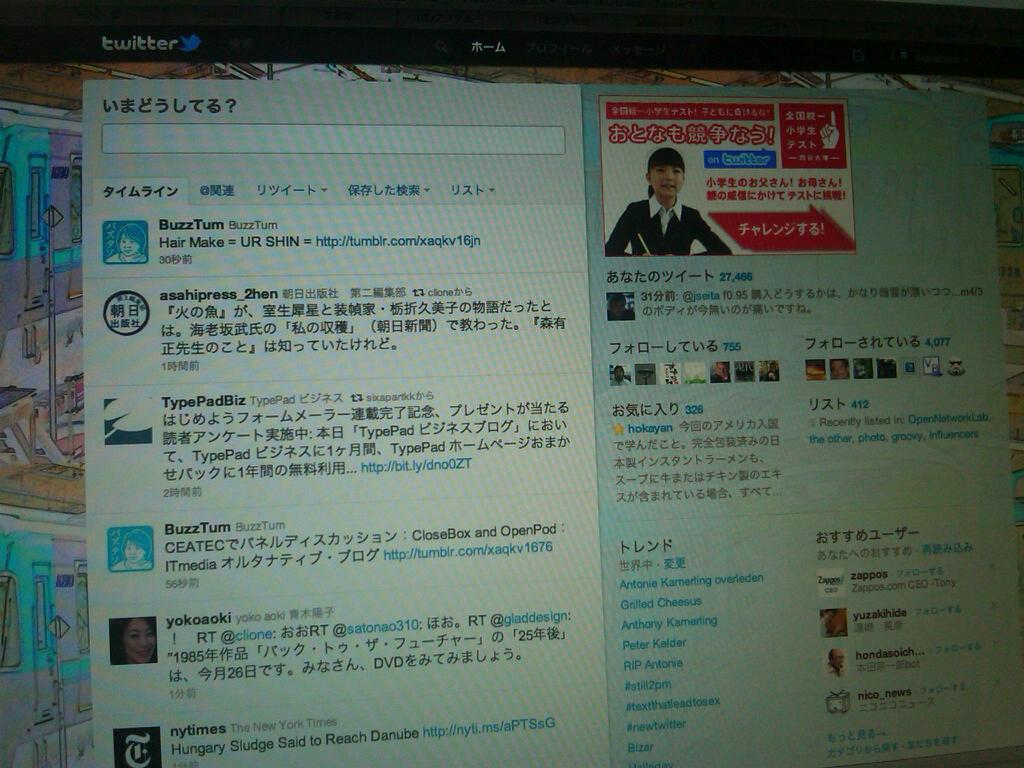Provide a one-sentence caption for the provided image. A monitor screen that has twitter on it and a profile up. 